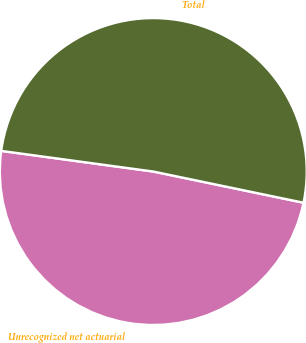Convert chart to OTSL. <chart><loc_0><loc_0><loc_500><loc_500><pie_chart><fcel>Unrecognized net actuarial<fcel>Total<nl><fcel>48.89%<fcel>51.11%<nl></chart> 